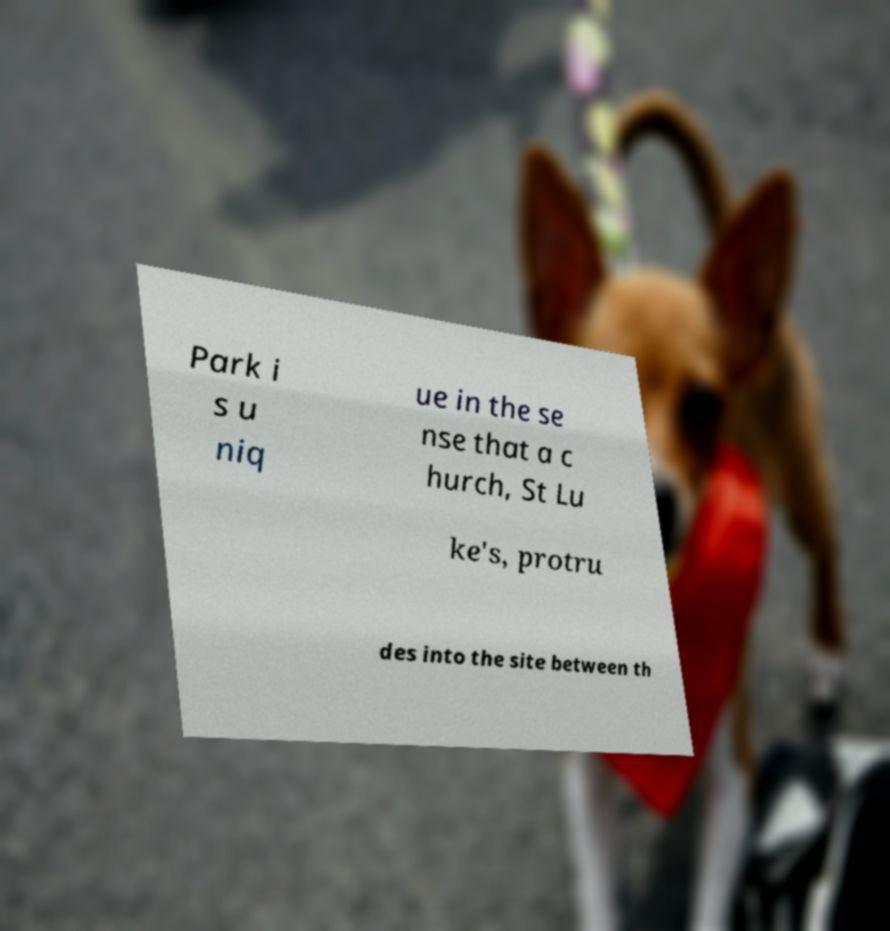Can you read and provide the text displayed in the image?This photo seems to have some interesting text. Can you extract and type it out for me? Park i s u niq ue in the se nse that a c hurch, St Lu ke's, protru des into the site between th 